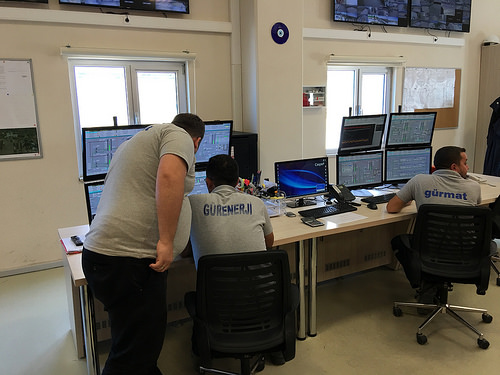<image>
Is there a man behind the man? Yes. From this viewpoint, the man is positioned behind the man, with the man partially or fully occluding the man. 